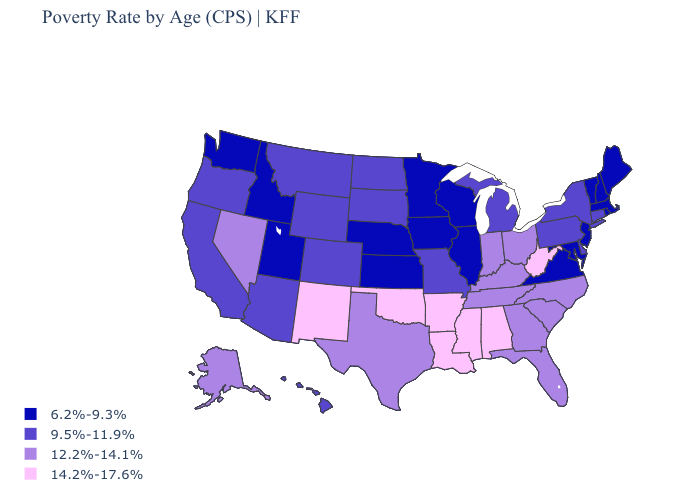Does South Dakota have a lower value than Alaska?
Quick response, please. Yes. Among the states that border Kentucky , which have the lowest value?
Quick response, please. Illinois, Virginia. Does Connecticut have the highest value in the USA?
Be succinct. No. Which states have the lowest value in the West?
Be succinct. Idaho, Utah, Washington. What is the lowest value in the USA?
Answer briefly. 6.2%-9.3%. What is the value of Connecticut?
Short answer required. 9.5%-11.9%. What is the value of Alabama?
Keep it brief. 14.2%-17.6%. Among the states that border Wisconsin , which have the lowest value?
Concise answer only. Illinois, Iowa, Minnesota. Does Hawaii have a higher value than North Dakota?
Give a very brief answer. No. What is the value of North Carolina?
Keep it brief. 12.2%-14.1%. Does Indiana have a higher value than Louisiana?
Concise answer only. No. What is the highest value in the Northeast ?
Write a very short answer. 9.5%-11.9%. Is the legend a continuous bar?
Quick response, please. No. What is the value of Tennessee?
Keep it brief. 12.2%-14.1%. What is the highest value in the USA?
Answer briefly. 14.2%-17.6%. 